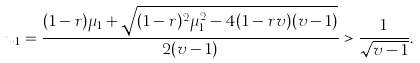<formula> <loc_0><loc_0><loc_500><loc_500>u _ { 1 } = \frac { ( 1 - r ) \mu _ { 1 } + \sqrt { ( 1 - r ) ^ { 2 } \mu _ { 1 } ^ { 2 } - 4 ( 1 - r v ) ( v - 1 ) } } { 2 ( v - 1 ) } > \frac { 1 } { \sqrt { v - 1 } } .</formula> 